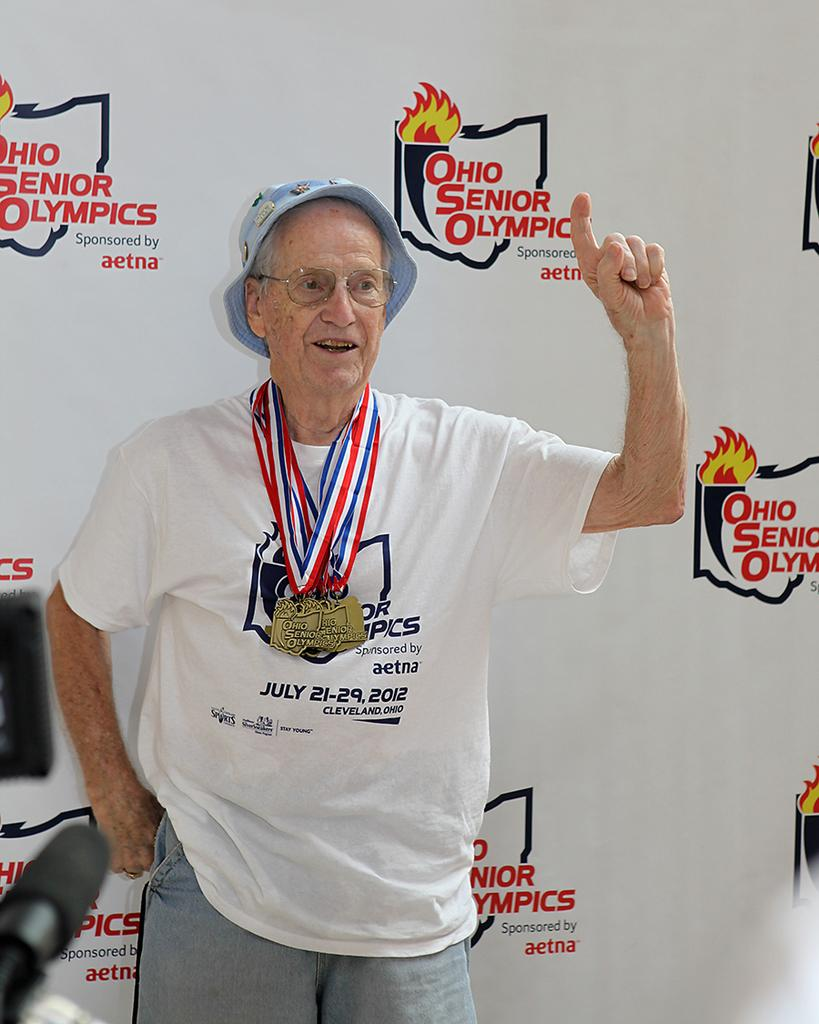Provide a one-sentence caption for the provided image. Old man wearing a shirt that has the month of July on it. 